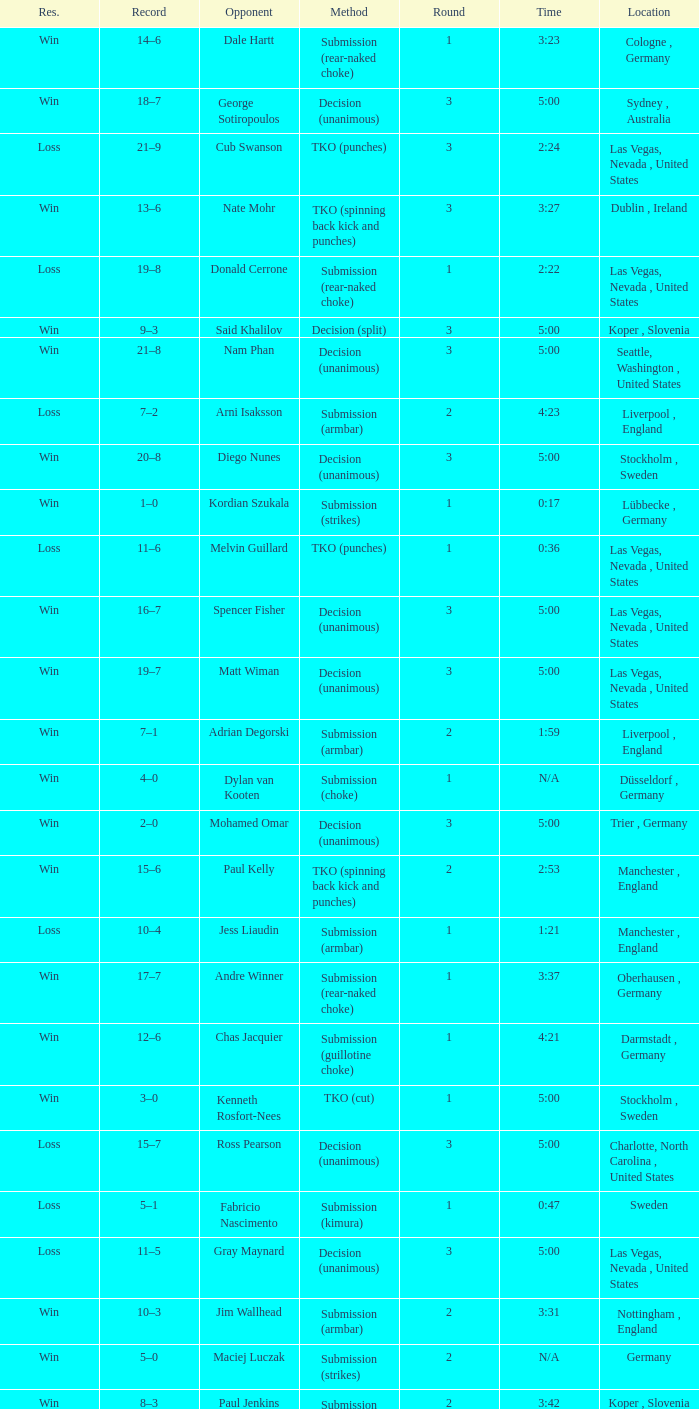Write the full table. {'header': ['Res.', 'Record', 'Opponent', 'Method', 'Round', 'Time', 'Location'], 'rows': [['Win', '14–6', 'Dale Hartt', 'Submission (rear-naked choke)', '1', '3:23', 'Cologne , Germany'], ['Win', '18–7', 'George Sotiropoulos', 'Decision (unanimous)', '3', '5:00', 'Sydney , Australia'], ['Loss', '21–9', 'Cub Swanson', 'TKO (punches)', '3', '2:24', 'Las Vegas, Nevada , United States'], ['Win', '13–6', 'Nate Mohr', 'TKO (spinning back kick and punches)', '3', '3:27', 'Dublin , Ireland'], ['Loss', '19–8', 'Donald Cerrone', 'Submission (rear-naked choke)', '1', '2:22', 'Las Vegas, Nevada , United States'], ['Win', '9–3', 'Said Khalilov', 'Decision (split)', '3', '5:00', 'Koper , Slovenia'], ['Win', '21–8', 'Nam Phan', 'Decision (unanimous)', '3', '5:00', 'Seattle, Washington , United States'], ['Loss', '7–2', 'Arni Isaksson', 'Submission (armbar)', '2', '4:23', 'Liverpool , England'], ['Win', '20–8', 'Diego Nunes', 'Decision (unanimous)', '3', '5:00', 'Stockholm , Sweden'], ['Win', '1–0', 'Kordian Szukala', 'Submission (strikes)', '1', '0:17', 'Lübbecke , Germany'], ['Loss', '11–6', 'Melvin Guillard', 'TKO (punches)', '1', '0:36', 'Las Vegas, Nevada , United States'], ['Win', '16–7', 'Spencer Fisher', 'Decision (unanimous)', '3', '5:00', 'Las Vegas, Nevada , United States'], ['Win', '19–7', 'Matt Wiman', 'Decision (unanimous)', '3', '5:00', 'Las Vegas, Nevada , United States'], ['Win', '7–1', 'Adrian Degorski', 'Submission (armbar)', '2', '1:59', 'Liverpool , England'], ['Win', '4–0', 'Dylan van Kooten', 'Submission (choke)', '1', 'N/A', 'Düsseldorf , Germany'], ['Win', '2–0', 'Mohamed Omar', 'Decision (unanimous)', '3', '5:00', 'Trier , Germany'], ['Win', '15–6', 'Paul Kelly', 'TKO (spinning back kick and punches)', '2', '2:53', 'Manchester , England'], ['Loss', '10–4', 'Jess Liaudin', 'Submission (armbar)', '1', '1:21', 'Manchester , England'], ['Win', '17–7', 'Andre Winner', 'Submission (rear-naked choke)', '1', '3:37', 'Oberhausen , Germany'], ['Win', '12–6', 'Chas Jacquier', 'Submission (guillotine choke)', '1', '4:21', 'Darmstadt , Germany'], ['Win', '3–0', 'Kenneth Rosfort-Nees', 'TKO (cut)', '1', '5:00', 'Stockholm , Sweden'], ['Loss', '15–7', 'Ross Pearson', 'Decision (unanimous)', '3', '5:00', 'Charlotte, North Carolina , United States'], ['Loss', '5–1', 'Fabricio Nascimento', 'Submission (kimura)', '1', '0:47', 'Sweden'], ['Loss', '11–5', 'Gray Maynard', 'Decision (unanimous)', '3', '5:00', 'Las Vegas, Nevada , United States'], ['Win', '10–3', 'Jim Wallhead', 'Submission (armbar)', '2', '3:31', 'Nottingham , England'], ['Win', '5–0', 'Maciej Luczak', 'Submission (strikes)', '2', 'N/A', 'Germany'], ['Win', '8–3', 'Paul Jenkins', 'Submission (heel hook)', '2', '3:42', 'Koper , Slovenia'], ['Win', '6–1', 'Jonas Ericsson', 'TKO (punches)', '1', '0:35', 'Liverpool , England'], ['Win', '11–4', 'Naoyuki Kotani', 'KO (punch)', '2', '2:04', 'London , England'], ['Loss', '7–3', 'Daniel Weichel', 'Submission (rear-naked choke)', '1', 'N/A', 'Darmstadt , Germany']]} What was the method of resolution for the fight against dale hartt? Submission (rear-naked choke). 